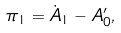Convert formula to latex. <formula><loc_0><loc_0><loc_500><loc_500>\pi _ { 1 } = \dot { A } _ { 1 } - { A } ^ { \prime } _ { 0 } ,</formula> 